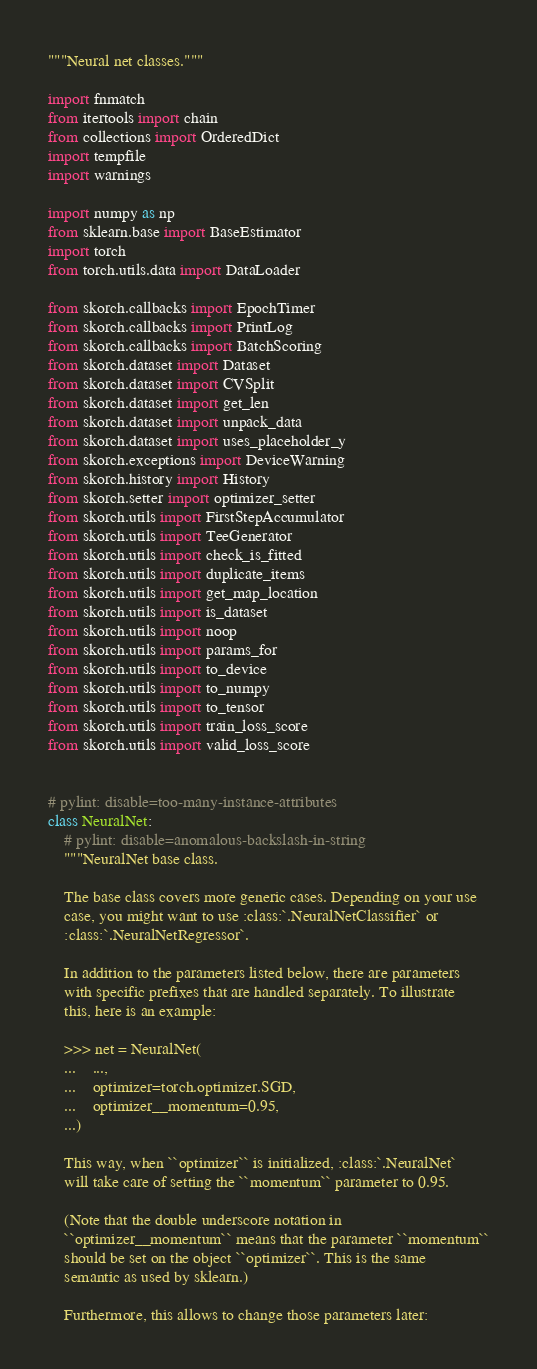Convert code to text. <code><loc_0><loc_0><loc_500><loc_500><_Python_>"""Neural net classes."""

import fnmatch
from itertools import chain
from collections import OrderedDict
import tempfile
import warnings

import numpy as np
from sklearn.base import BaseEstimator
import torch
from torch.utils.data import DataLoader

from skorch.callbacks import EpochTimer
from skorch.callbacks import PrintLog
from skorch.callbacks import BatchScoring
from skorch.dataset import Dataset
from skorch.dataset import CVSplit
from skorch.dataset import get_len
from skorch.dataset import unpack_data
from skorch.dataset import uses_placeholder_y
from skorch.exceptions import DeviceWarning
from skorch.history import History
from skorch.setter import optimizer_setter
from skorch.utils import FirstStepAccumulator
from skorch.utils import TeeGenerator
from skorch.utils import check_is_fitted
from skorch.utils import duplicate_items
from skorch.utils import get_map_location
from skorch.utils import is_dataset
from skorch.utils import noop
from skorch.utils import params_for
from skorch.utils import to_device
from skorch.utils import to_numpy
from skorch.utils import to_tensor
from skorch.utils import train_loss_score
from skorch.utils import valid_loss_score


# pylint: disable=too-many-instance-attributes
class NeuralNet:
    # pylint: disable=anomalous-backslash-in-string
    """NeuralNet base class.

    The base class covers more generic cases. Depending on your use
    case, you might want to use :class:`.NeuralNetClassifier` or
    :class:`.NeuralNetRegressor`.

    In addition to the parameters listed below, there are parameters
    with specific prefixes that are handled separately. To illustrate
    this, here is an example:

    >>> net = NeuralNet(
    ...    ...,
    ...    optimizer=torch.optimizer.SGD,
    ...    optimizer__momentum=0.95,
    ...)

    This way, when ``optimizer`` is initialized, :class:`.NeuralNet`
    will take care of setting the ``momentum`` parameter to 0.95.

    (Note that the double underscore notation in
    ``optimizer__momentum`` means that the parameter ``momentum``
    should be set on the object ``optimizer``. This is the same
    semantic as used by sklearn.)

    Furthermore, this allows to change those parameters later:
</code> 